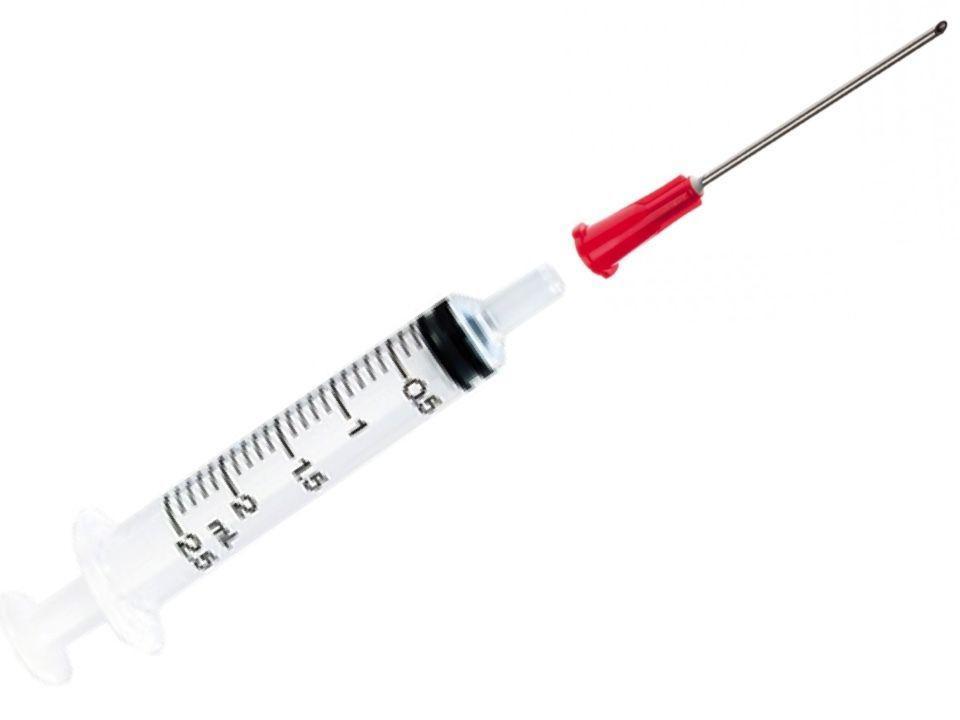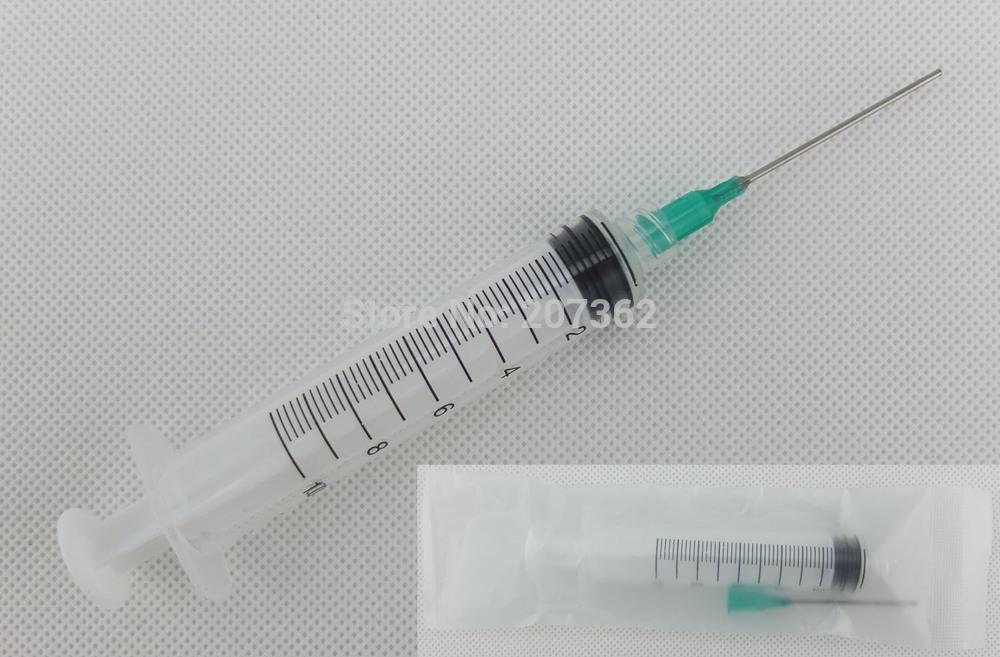The first image is the image on the left, the second image is the image on the right. Analyze the images presented: Is the assertion "One of the images shows a single syringe and another image shows two syringes that are parallel to one another." valid? Answer yes or no. No. 